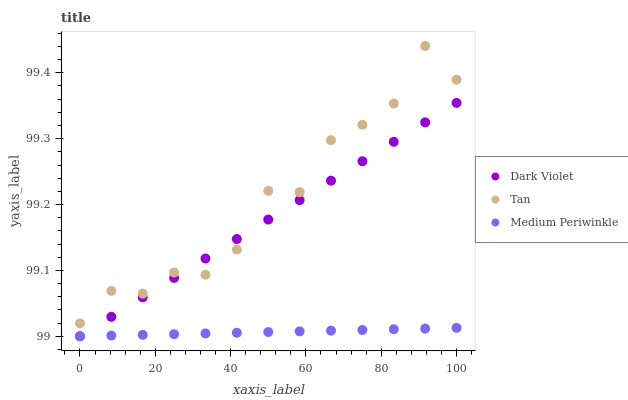Does Medium Periwinkle have the minimum area under the curve?
Answer yes or no. Yes. Does Tan have the maximum area under the curve?
Answer yes or no. Yes. Does Dark Violet have the minimum area under the curve?
Answer yes or no. No. Does Dark Violet have the maximum area under the curve?
Answer yes or no. No. Is Medium Periwinkle the smoothest?
Answer yes or no. Yes. Is Tan the roughest?
Answer yes or no. Yes. Is Dark Violet the smoothest?
Answer yes or no. No. Is Dark Violet the roughest?
Answer yes or no. No. Does Medium Periwinkle have the lowest value?
Answer yes or no. Yes. Does Tan have the highest value?
Answer yes or no. Yes. Does Dark Violet have the highest value?
Answer yes or no. No. Is Medium Periwinkle less than Tan?
Answer yes or no. Yes. Is Tan greater than Medium Periwinkle?
Answer yes or no. Yes. Does Tan intersect Dark Violet?
Answer yes or no. Yes. Is Tan less than Dark Violet?
Answer yes or no. No. Is Tan greater than Dark Violet?
Answer yes or no. No. Does Medium Periwinkle intersect Tan?
Answer yes or no. No. 